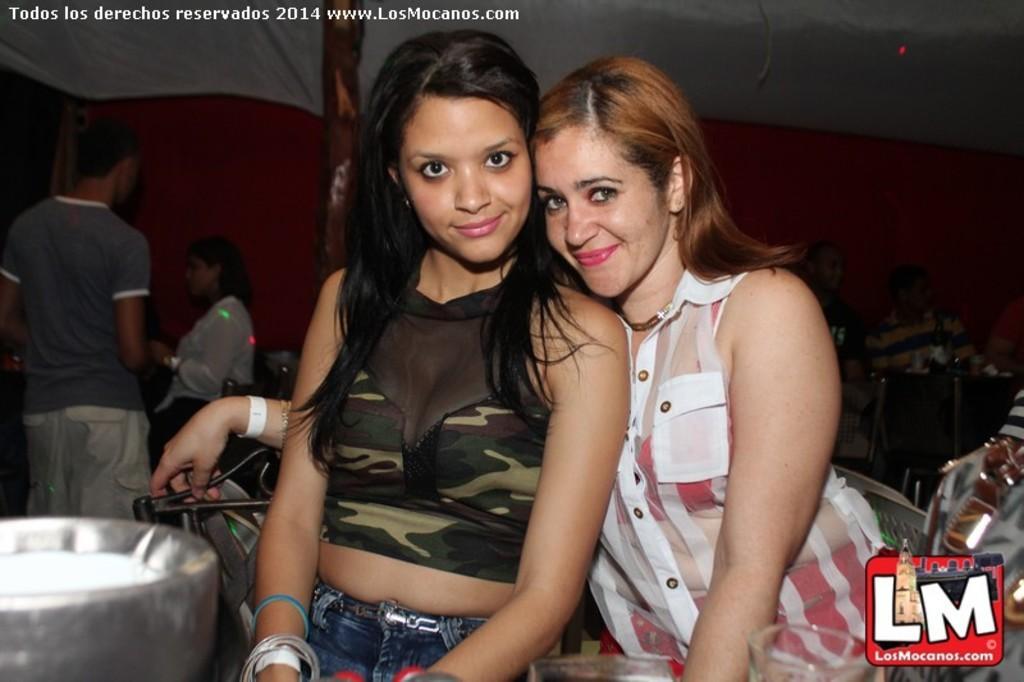How would you summarize this image in a sentence or two? In this image I can see number of people where one is standing and rest all are sitting on chairs. In the front I can see smile on two faces. On the top left side and on the bottom right corner of this image I can see watermarks. On the bottom left side of this image I can see a silver colour thing and I can also see few lights in the background. 